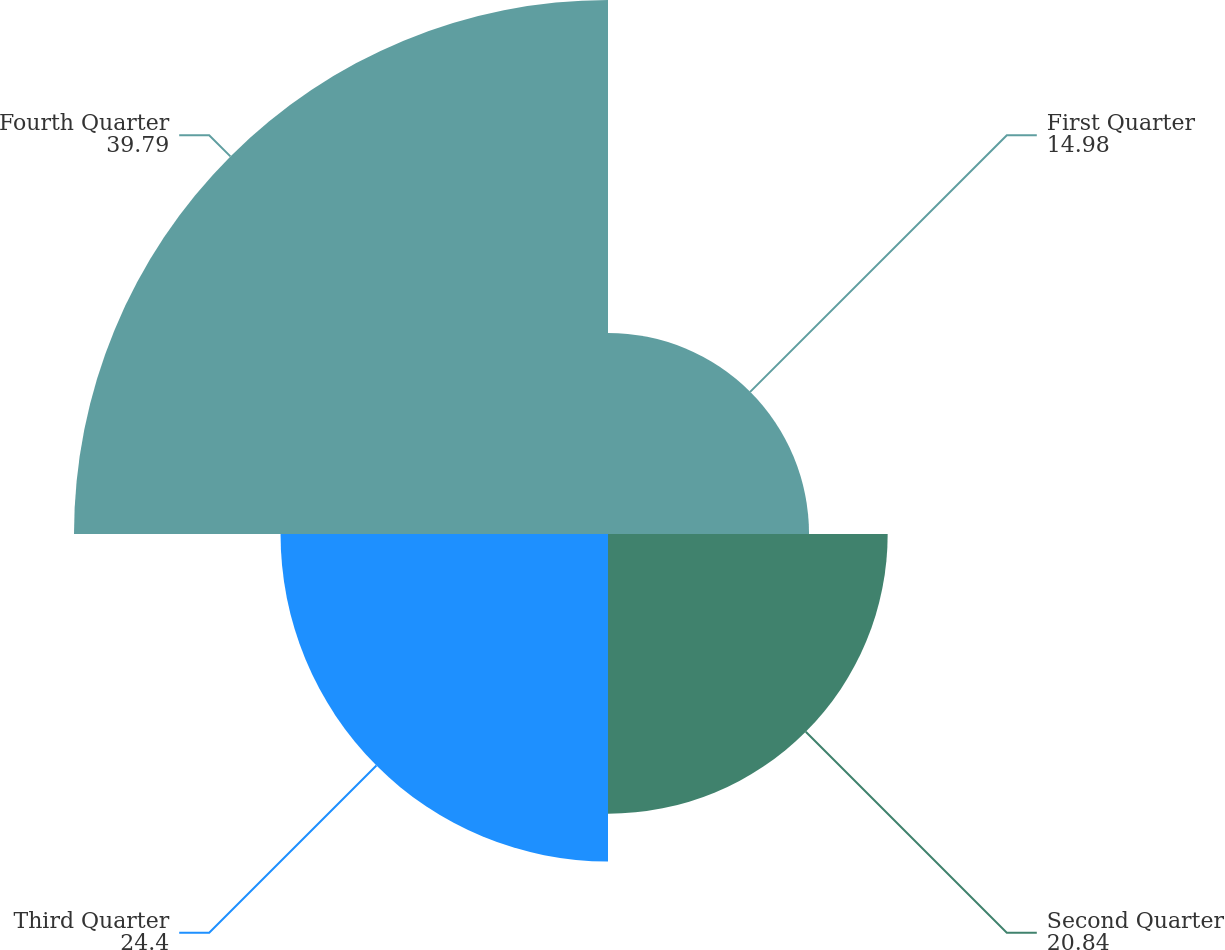Convert chart to OTSL. <chart><loc_0><loc_0><loc_500><loc_500><pie_chart><fcel>First Quarter<fcel>Second Quarter<fcel>Third Quarter<fcel>Fourth Quarter<nl><fcel>14.98%<fcel>20.84%<fcel>24.4%<fcel>39.79%<nl></chart> 